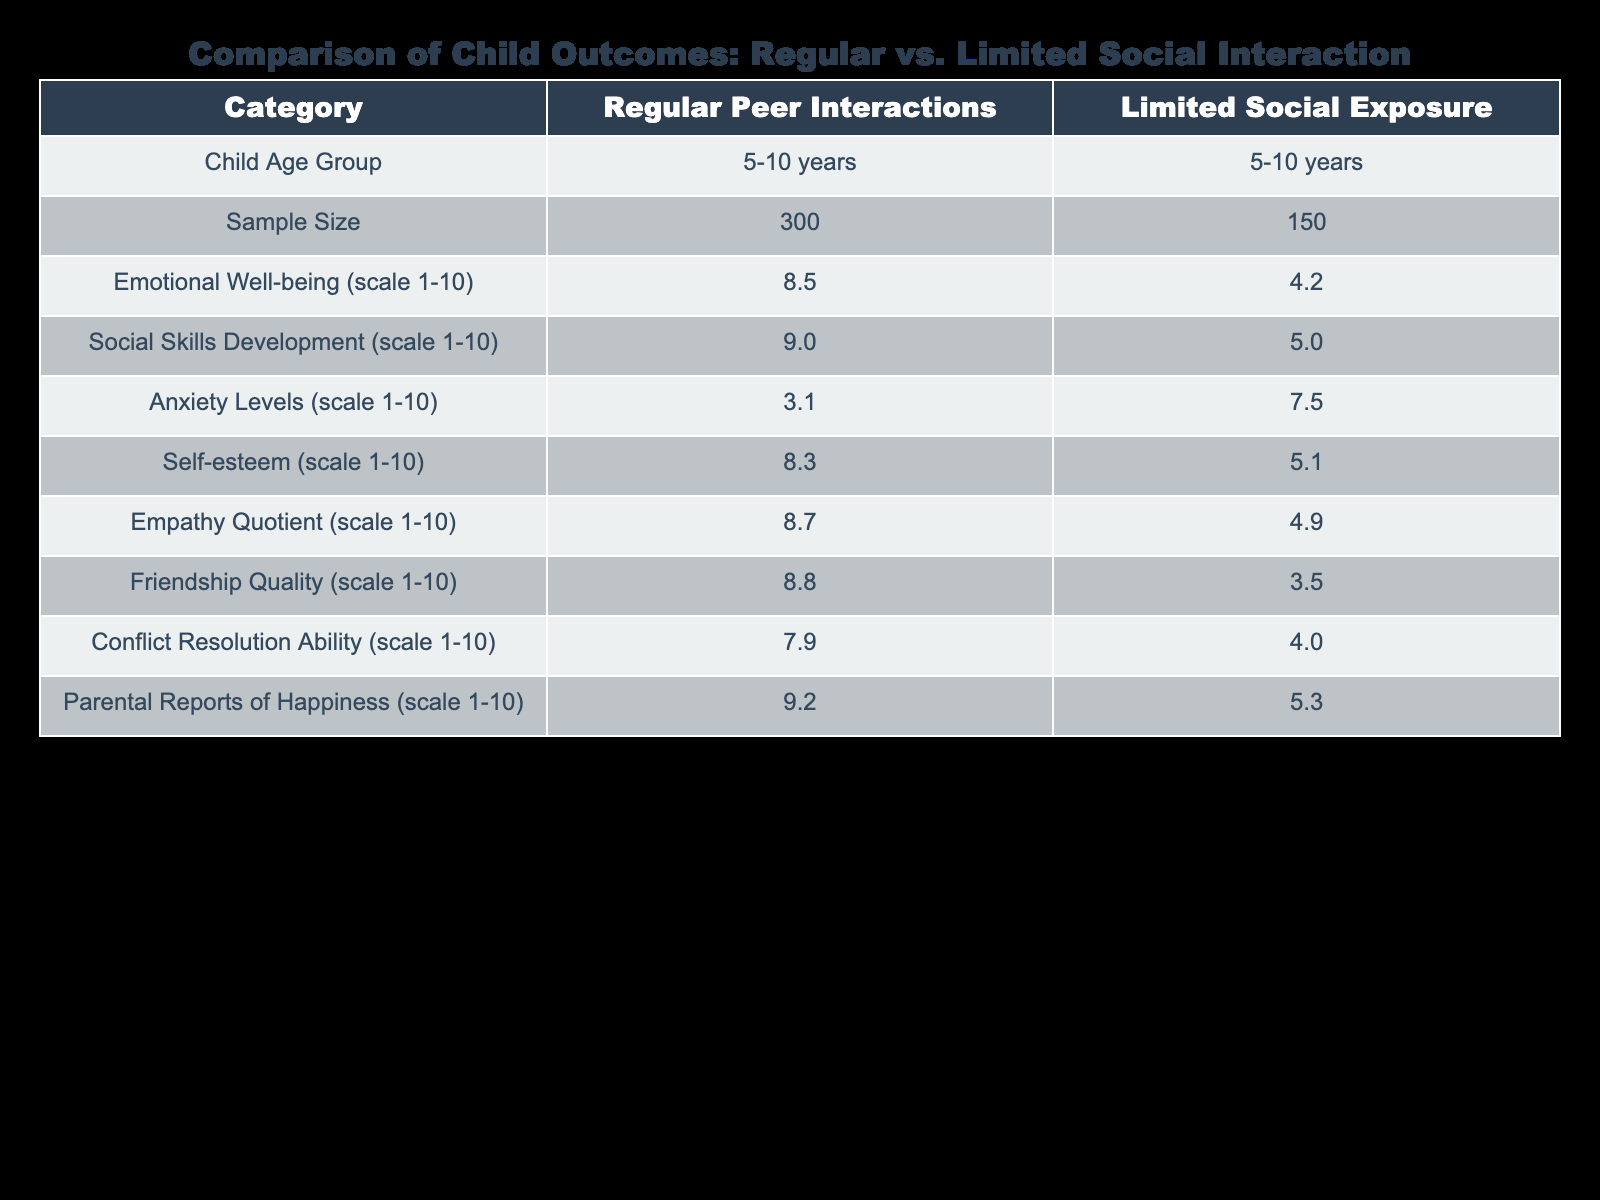What is the emotional well-being score for children with regular peer interactions? The emotional well-being score is directly available in the table under the "Emotional Well-being (scale 1-10)" row for "Regular Peer Interactions," which shows a value of 8.5.
Answer: 8.5 What is the friendship quality score for children with limited social exposure? The friendship quality score can be found in the table under the "Friendship Quality (scale 1-10)" row for "Limited Social Exposure," which lists a score of 3.5.
Answer: 3.5 What is the difference in social skills development between the two groups? To find the difference in social skills development, we compare the scores from each group: 9.0 (Regular Peer Interactions) minus 5.0 (Limited Social Exposure) equals 4.0.
Answer: 4.0 Is the self-esteem level higher for children with regular peer interactions than for those with limited social exposure? By comparing the self-esteem scores of 8.3 for "Regular Peer Interactions" and 5.1 for "Limited Social Exposure," we confirm that 8.3 is greater than 5.1, indicating that self-esteem is indeed higher for the former group.
Answer: Yes What is the average empathy quotient for children with limited social exposure? There is only one empathy quotient value for the "Limited Social Exposure" group, which is 4.9. Consequently, the average is simply that value: 4.9.
Answer: 4.9 How do anxiety levels compare between the two groups? The anxiety level for "Regular Peer Interactions" is 3.1, while it is 7.5 for "Limited Social Exposure." This shows that anxiety levels are higher in the group with limited social exposure.
Answer: Higher in limited social exposure What is the score for parental reports of happiness for children with regular peer interactions? The score for parental reports of happiness is specified under the corresponding column in the table. For "Regular Peer Interactions," this value is 9.2.
Answer: 9.2 What is the combined total score for emotional well-being and self-esteem for children with regular peer interactions? To find the combined total score, we sum the emotional well-being score (8.5) and the self-esteem score (8.3) for "Regular Peer Interactions." The calculation is 8.5 + 8.3 = 16.8.
Answer: 16.8 What can be inferred about the conflict resolution ability of children with regular peer interactions compared to those with limited social exposure? The conflict resolution ability for "Regular Peer Interactions" is 7.9, while for "Limited Social Exposure," it is 4.0. Thus, children with regular peer interactions show significantly better conflict resolution skills compared to those with limited social exposure.
Answer: Better in regular peer interactions 